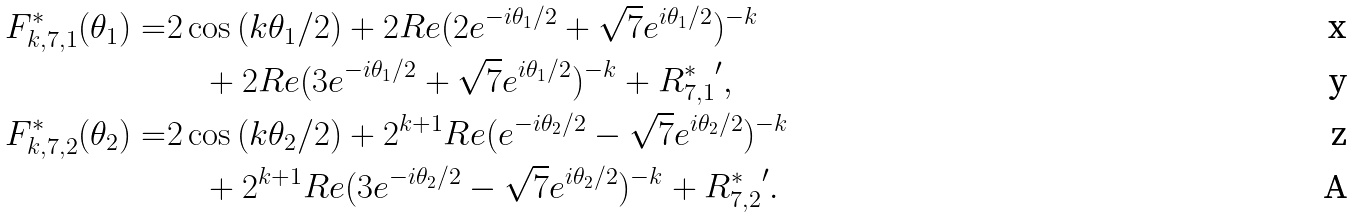<formula> <loc_0><loc_0><loc_500><loc_500>F _ { k , 7 , 1 } ^ { * } ( \theta _ { 1 } ) = & 2 \cos \left ( k \theta _ { 1 } / 2 \right ) + 2 R e ( 2 e ^ { - i \theta _ { 1 } / 2 } + \sqrt { 7 } e ^ { i \theta _ { 1 } / 2 } ) ^ { - k } \\ & \quad + 2 R e ( 3 e ^ { - i \theta _ { 1 } / 2 } + \sqrt { 7 } e ^ { i \theta _ { 1 } / 2 } ) ^ { - k } + { R _ { 7 , 1 } ^ { * } } ^ { \prime } , \\ F _ { k , 7 , 2 } ^ { * } ( \theta _ { 2 } ) = & 2 \cos \left ( k \theta _ { 2 } / 2 \right ) + 2 ^ { k + 1 } R e ( e ^ { - i \theta _ { 2 } / 2 } - \sqrt { 7 } e ^ { i \theta _ { 2 } / 2 } ) ^ { - k } \\ & \quad + 2 ^ { k + 1 } R e ( 3 e ^ { - i \theta _ { 2 } / 2 } - \sqrt { 7 } e ^ { i \theta _ { 2 } / 2 } ) ^ { - k } + { R _ { 7 , 2 } ^ { * } } ^ { \prime } .</formula> 